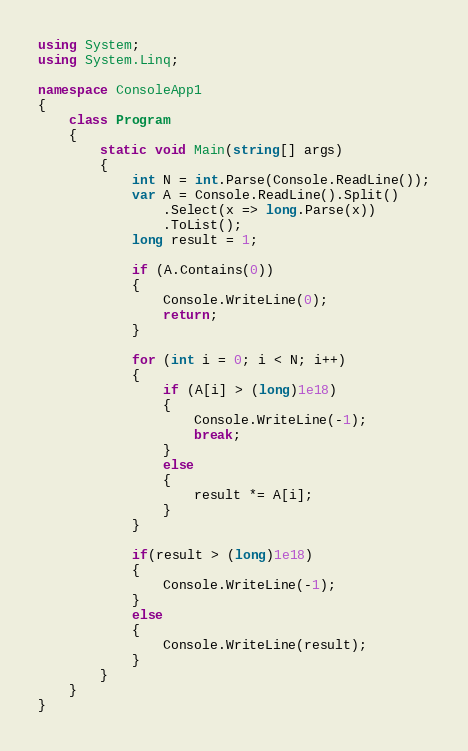<code> <loc_0><loc_0><loc_500><loc_500><_C#_>using System;
using System.Linq;

namespace ConsoleApp1
{
    class Program
    {
        static void Main(string[] args)
        {
            int N = int.Parse(Console.ReadLine());
            var A = Console.ReadLine().Split()
                .Select(x => long.Parse(x))
                .ToList();
            long result = 1;

            if (A.Contains(0))
            {
                Console.WriteLine(0);
                return;
            }

            for (int i = 0; i < N; i++)
            {
                if (A[i] > (long)1e18)
                {
                    Console.WriteLine(-1);
                    break;
                }
                else
                {
                    result *= A[i];
                }
            }

            if(result > (long)1e18)
            {
                Console.WriteLine(-1);
            }
            else
            {
                Console.WriteLine(result);
            }
        }
    }
}</code> 